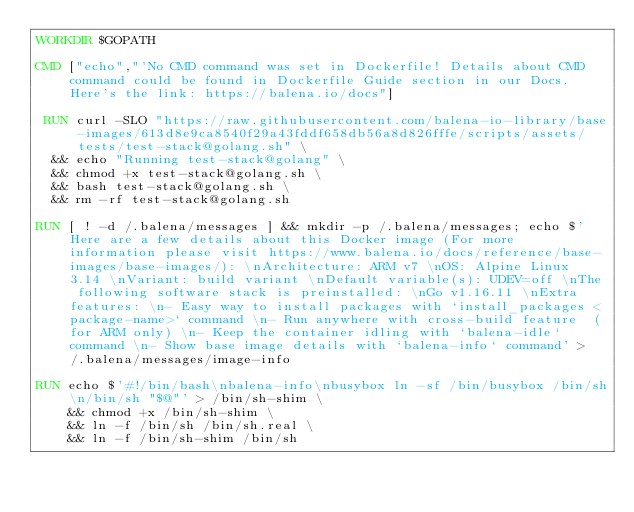<code> <loc_0><loc_0><loc_500><loc_500><_Dockerfile_>WORKDIR $GOPATH

CMD ["echo","'No CMD command was set in Dockerfile! Details about CMD command could be found in Dockerfile Guide section in our Docs. Here's the link: https://balena.io/docs"]

 RUN curl -SLO "https://raw.githubusercontent.com/balena-io-library/base-images/613d8e9ca8540f29a43fddf658db56a8d826fffe/scripts/assets/tests/test-stack@golang.sh" \
  && echo "Running test-stack@golang" \
  && chmod +x test-stack@golang.sh \
  && bash test-stack@golang.sh \
  && rm -rf test-stack@golang.sh 

RUN [ ! -d /.balena/messages ] && mkdir -p /.balena/messages; echo $'Here are a few details about this Docker image (For more information please visit https://www.balena.io/docs/reference/base-images/base-images/): \nArchitecture: ARM v7 \nOS: Alpine Linux 3.14 \nVariant: build variant \nDefault variable(s): UDEV=off \nThe following software stack is preinstalled: \nGo v1.16.11 \nExtra features: \n- Easy way to install packages with `install_packages <package-name>` command \n- Run anywhere with cross-build feature  (for ARM only) \n- Keep the container idling with `balena-idle` command \n- Show base image details with `balena-info` command' > /.balena/messages/image-info

RUN echo $'#!/bin/bash\nbalena-info\nbusybox ln -sf /bin/busybox /bin/sh\n/bin/sh "$@"' > /bin/sh-shim \
	&& chmod +x /bin/sh-shim \
	&& ln -f /bin/sh /bin/sh.real \
	&& ln -f /bin/sh-shim /bin/sh</code> 